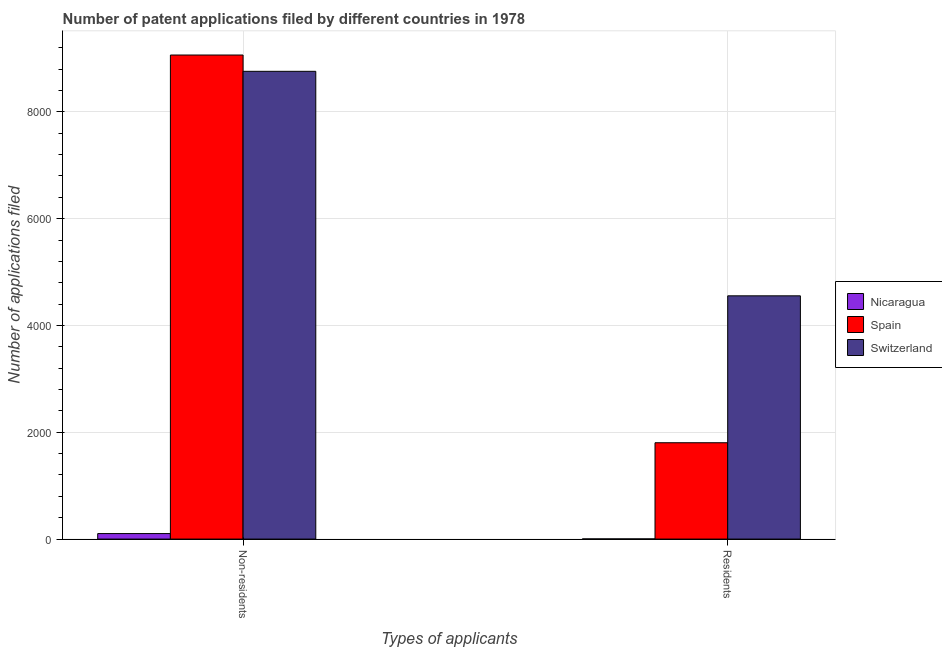How many groups of bars are there?
Your response must be concise. 2. Are the number of bars per tick equal to the number of legend labels?
Offer a very short reply. Yes. Are the number of bars on each tick of the X-axis equal?
Provide a succinct answer. Yes. What is the label of the 1st group of bars from the left?
Offer a very short reply. Non-residents. What is the number of patent applications by residents in Spain?
Give a very brief answer. 1804. Across all countries, what is the maximum number of patent applications by non residents?
Your answer should be compact. 9064. Across all countries, what is the minimum number of patent applications by non residents?
Make the answer very short. 103. In which country was the number of patent applications by residents minimum?
Keep it short and to the point. Nicaragua. What is the total number of patent applications by non residents in the graph?
Provide a succinct answer. 1.79e+04. What is the difference between the number of patent applications by non residents in Nicaragua and that in Switzerland?
Offer a very short reply. -8656. What is the difference between the number of patent applications by residents in Switzerland and the number of patent applications by non residents in Spain?
Provide a short and direct response. -4509. What is the average number of patent applications by residents per country?
Your answer should be very brief. 2120.67. What is the difference between the number of patent applications by residents and number of patent applications by non residents in Spain?
Offer a terse response. -7260. In how many countries, is the number of patent applications by non residents greater than 5600 ?
Keep it short and to the point. 2. What is the ratio of the number of patent applications by residents in Nicaragua to that in Switzerland?
Provide a short and direct response. 0. In how many countries, is the number of patent applications by residents greater than the average number of patent applications by residents taken over all countries?
Offer a terse response. 1. What does the 1st bar from the left in Residents represents?
Offer a very short reply. Nicaragua. What does the 1st bar from the right in Non-residents represents?
Keep it short and to the point. Switzerland. How many bars are there?
Make the answer very short. 6. Are the values on the major ticks of Y-axis written in scientific E-notation?
Provide a succinct answer. No. Where does the legend appear in the graph?
Keep it short and to the point. Center right. How are the legend labels stacked?
Give a very brief answer. Vertical. What is the title of the graph?
Offer a very short reply. Number of patent applications filed by different countries in 1978. What is the label or title of the X-axis?
Offer a very short reply. Types of applicants. What is the label or title of the Y-axis?
Your answer should be very brief. Number of applications filed. What is the Number of applications filed of Nicaragua in Non-residents?
Your response must be concise. 103. What is the Number of applications filed of Spain in Non-residents?
Keep it short and to the point. 9064. What is the Number of applications filed in Switzerland in Non-residents?
Your response must be concise. 8759. What is the Number of applications filed of Nicaragua in Residents?
Give a very brief answer. 3. What is the Number of applications filed in Spain in Residents?
Your response must be concise. 1804. What is the Number of applications filed of Switzerland in Residents?
Your answer should be compact. 4555. Across all Types of applicants, what is the maximum Number of applications filed in Nicaragua?
Provide a short and direct response. 103. Across all Types of applicants, what is the maximum Number of applications filed of Spain?
Offer a very short reply. 9064. Across all Types of applicants, what is the maximum Number of applications filed of Switzerland?
Ensure brevity in your answer.  8759. Across all Types of applicants, what is the minimum Number of applications filed in Nicaragua?
Your answer should be very brief. 3. Across all Types of applicants, what is the minimum Number of applications filed of Spain?
Your response must be concise. 1804. Across all Types of applicants, what is the minimum Number of applications filed of Switzerland?
Make the answer very short. 4555. What is the total Number of applications filed of Nicaragua in the graph?
Your answer should be compact. 106. What is the total Number of applications filed in Spain in the graph?
Your answer should be compact. 1.09e+04. What is the total Number of applications filed of Switzerland in the graph?
Make the answer very short. 1.33e+04. What is the difference between the Number of applications filed of Spain in Non-residents and that in Residents?
Offer a terse response. 7260. What is the difference between the Number of applications filed in Switzerland in Non-residents and that in Residents?
Give a very brief answer. 4204. What is the difference between the Number of applications filed in Nicaragua in Non-residents and the Number of applications filed in Spain in Residents?
Offer a very short reply. -1701. What is the difference between the Number of applications filed of Nicaragua in Non-residents and the Number of applications filed of Switzerland in Residents?
Offer a very short reply. -4452. What is the difference between the Number of applications filed in Spain in Non-residents and the Number of applications filed in Switzerland in Residents?
Offer a terse response. 4509. What is the average Number of applications filed in Spain per Types of applicants?
Offer a very short reply. 5434. What is the average Number of applications filed of Switzerland per Types of applicants?
Your answer should be very brief. 6657. What is the difference between the Number of applications filed of Nicaragua and Number of applications filed of Spain in Non-residents?
Your response must be concise. -8961. What is the difference between the Number of applications filed of Nicaragua and Number of applications filed of Switzerland in Non-residents?
Provide a succinct answer. -8656. What is the difference between the Number of applications filed in Spain and Number of applications filed in Switzerland in Non-residents?
Your answer should be very brief. 305. What is the difference between the Number of applications filed of Nicaragua and Number of applications filed of Spain in Residents?
Make the answer very short. -1801. What is the difference between the Number of applications filed of Nicaragua and Number of applications filed of Switzerland in Residents?
Offer a very short reply. -4552. What is the difference between the Number of applications filed in Spain and Number of applications filed in Switzerland in Residents?
Provide a succinct answer. -2751. What is the ratio of the Number of applications filed in Nicaragua in Non-residents to that in Residents?
Offer a very short reply. 34.33. What is the ratio of the Number of applications filed in Spain in Non-residents to that in Residents?
Make the answer very short. 5.02. What is the ratio of the Number of applications filed of Switzerland in Non-residents to that in Residents?
Provide a succinct answer. 1.92. What is the difference between the highest and the second highest Number of applications filed of Nicaragua?
Offer a terse response. 100. What is the difference between the highest and the second highest Number of applications filed of Spain?
Your answer should be very brief. 7260. What is the difference between the highest and the second highest Number of applications filed in Switzerland?
Provide a short and direct response. 4204. What is the difference between the highest and the lowest Number of applications filed of Nicaragua?
Offer a terse response. 100. What is the difference between the highest and the lowest Number of applications filed of Spain?
Offer a terse response. 7260. What is the difference between the highest and the lowest Number of applications filed in Switzerland?
Make the answer very short. 4204. 